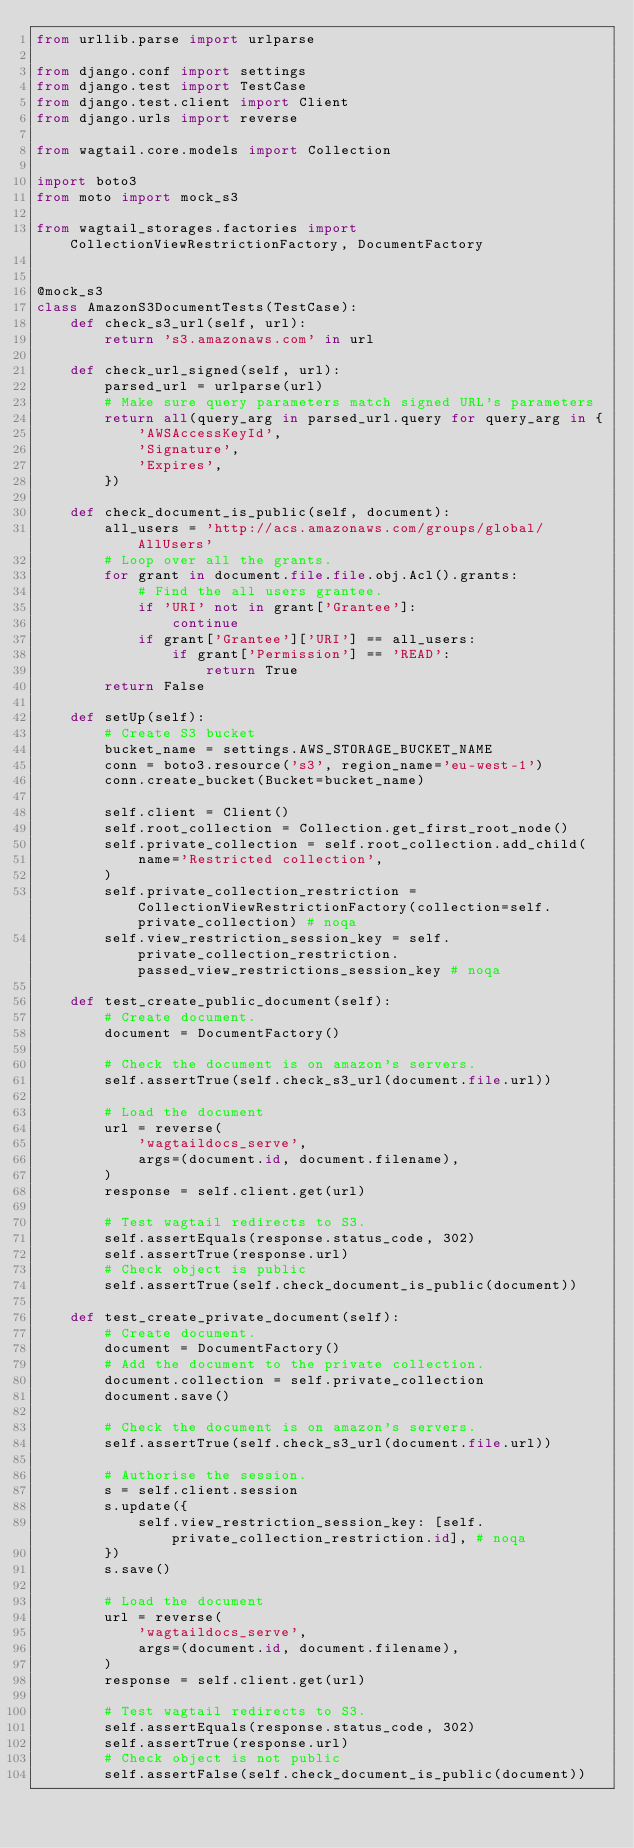Convert code to text. <code><loc_0><loc_0><loc_500><loc_500><_Python_>from urllib.parse import urlparse

from django.conf import settings
from django.test import TestCase
from django.test.client import Client
from django.urls import reverse

from wagtail.core.models import Collection

import boto3
from moto import mock_s3

from wagtail_storages.factories import CollectionViewRestrictionFactory, DocumentFactory


@mock_s3
class AmazonS3DocumentTests(TestCase):
    def check_s3_url(self, url):
        return 's3.amazonaws.com' in url

    def check_url_signed(self, url):
        parsed_url = urlparse(url)
        # Make sure query parameters match signed URL's parameters
        return all(query_arg in parsed_url.query for query_arg in {
            'AWSAccessKeyId',
            'Signature',
            'Expires',
        })

    def check_document_is_public(self, document):
        all_users = 'http://acs.amazonaws.com/groups/global/AllUsers'
        # Loop over all the grants.
        for grant in document.file.file.obj.Acl().grants:
            # Find the all users grantee.
            if 'URI' not in grant['Grantee']:
                continue
            if grant['Grantee']['URI'] == all_users:
                if grant['Permission'] == 'READ':
                    return True
        return False

    def setUp(self):
        # Create S3 bucket
        bucket_name = settings.AWS_STORAGE_BUCKET_NAME
        conn = boto3.resource('s3', region_name='eu-west-1')
        conn.create_bucket(Bucket=bucket_name)

        self.client = Client()
        self.root_collection = Collection.get_first_root_node()
        self.private_collection = self.root_collection.add_child(
            name='Restricted collection',
        )
        self.private_collection_restriction = CollectionViewRestrictionFactory(collection=self.private_collection) # noqa
        self.view_restriction_session_key = self.private_collection_restriction.passed_view_restrictions_session_key # noqa

    def test_create_public_document(self):
        # Create document.
        document = DocumentFactory()

        # Check the document is on amazon's servers.
        self.assertTrue(self.check_s3_url(document.file.url))

        # Load the document
        url = reverse(
            'wagtaildocs_serve',
            args=(document.id, document.filename),
        )
        response = self.client.get(url)

        # Test wagtail redirects to S3.
        self.assertEquals(response.status_code, 302)
        self.assertTrue(response.url)
        # Check object is public
        self.assertTrue(self.check_document_is_public(document))

    def test_create_private_document(self):
        # Create document.
        document = DocumentFactory()
        # Add the document to the private collection.
        document.collection = self.private_collection
        document.save()

        # Check the document is on amazon's servers.
        self.assertTrue(self.check_s3_url(document.file.url))

        # Authorise the session.
        s = self.client.session
        s.update({
            self.view_restriction_session_key: [self.private_collection_restriction.id], # noqa
        })
        s.save()

        # Load the document
        url = reverse(
            'wagtaildocs_serve',
            args=(document.id, document.filename),
        )
        response = self.client.get(url)

        # Test wagtail redirects to S3.
        self.assertEquals(response.status_code, 302)
        self.assertTrue(response.url)
        # Check object is not public
        self.assertFalse(self.check_document_is_public(document))
</code> 